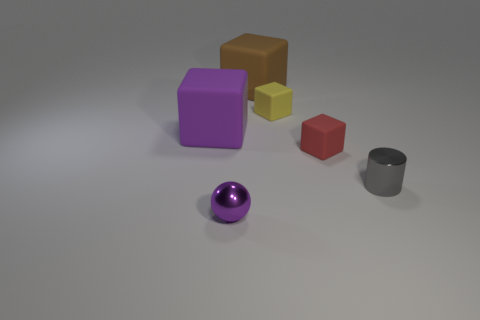What color is the small cylinder?
Keep it short and to the point. Gray. What number of rubber things are small purple balls or small cyan objects?
Provide a succinct answer. 0. How big is the metal object that is on the left side of the small block on the left side of the tiny red cube right of the big purple object?
Your answer should be compact. Small. There is a object that is both right of the small yellow matte block and on the left side of the cylinder; what size is it?
Offer a terse response. Small. There is a small cube to the right of the yellow object; is it the same color as the tiny metal thing in front of the tiny gray metal cylinder?
Offer a very short reply. No. How many big rubber objects are in front of the small purple object?
Keep it short and to the point. 0. Is there a gray cylinder to the left of the big object on the right side of the shiny object on the left side of the tiny red object?
Provide a short and direct response. No. What number of other rubber things are the same size as the yellow object?
Your answer should be very brief. 1. What material is the cube left of the shiny thing that is in front of the gray metallic cylinder?
Keep it short and to the point. Rubber. What is the shape of the tiny thing that is behind the purple object that is behind the tiny metal object right of the brown rubber cube?
Your response must be concise. Cube. 